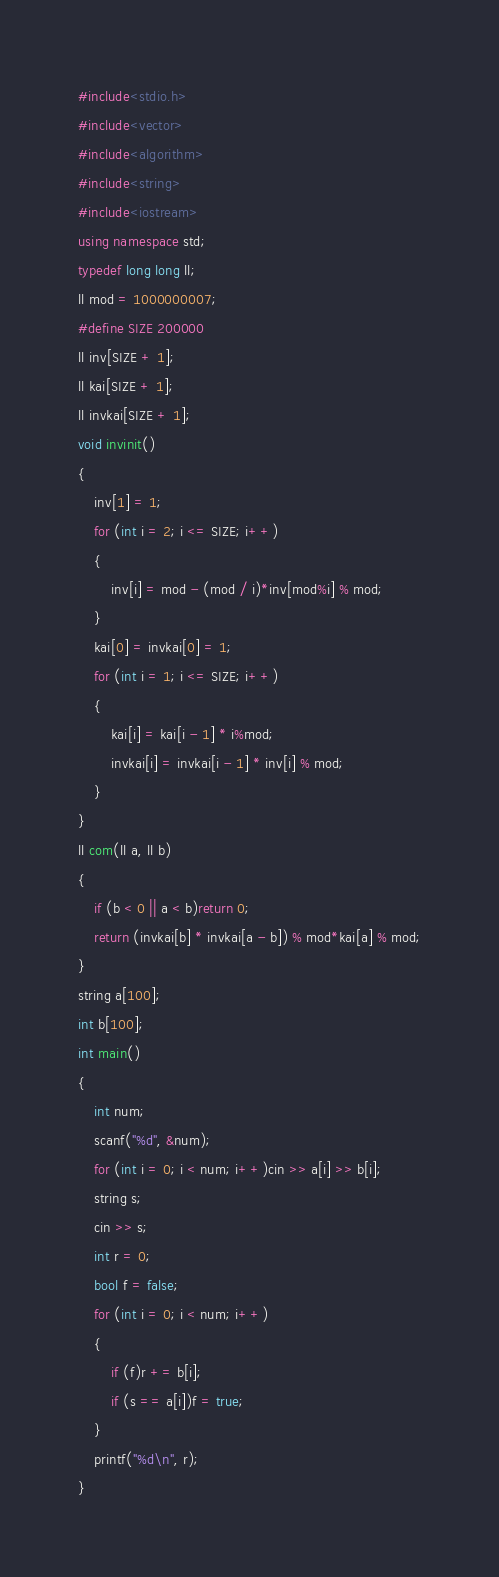Convert code to text. <code><loc_0><loc_0><loc_500><loc_500><_C++_>#include<stdio.h>
#include<vector>
#include<algorithm>
#include<string>
#include<iostream>
using namespace std;
typedef long long ll;
ll mod = 1000000007;
#define SIZE 200000
ll inv[SIZE + 1];
ll kai[SIZE + 1];
ll invkai[SIZE + 1];
void invinit()
{
	inv[1] = 1;
	for (int i = 2; i <= SIZE; i++)
	{
		inv[i] = mod - (mod / i)*inv[mod%i] % mod;
	}
	kai[0] = invkai[0] = 1;
	for (int i = 1; i <= SIZE; i++)
	{
		kai[i] = kai[i - 1] * i%mod;
		invkai[i] = invkai[i - 1] * inv[i] % mod;
	}
}
ll com(ll a, ll b)
{
	if (b < 0 || a < b)return 0;
	return (invkai[b] * invkai[a - b]) % mod*kai[a] % mod;
}
string a[100];
int b[100];
int main()
{
	int num;
	scanf("%d", &num);
	for (int i = 0; i < num; i++)cin >> a[i] >> b[i];
	string s;
	cin >> s;
	int r = 0;
	bool f = false;
	for (int i = 0; i < num; i++)
	{
		if (f)r += b[i];
		if (s == a[i])f = true;
	}
	printf("%d\n", r);
}</code> 